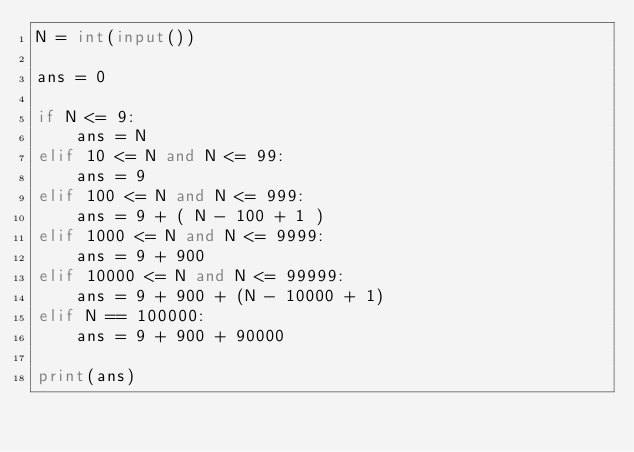Convert code to text. <code><loc_0><loc_0><loc_500><loc_500><_Python_>N = int(input())

ans = 0

if N <= 9:
    ans = N
elif 10 <= N and N <= 99:
    ans = 9
elif 100 <= N and N <= 999:
    ans = 9 + ( N - 100 + 1 )
elif 1000 <= N and N <= 9999:
    ans = 9 + 900
elif 10000 <= N and N <= 99999:
    ans = 9 + 900 + (N - 10000 + 1)
elif N == 100000:
    ans = 9 + 900 + 90000
    
print(ans)</code> 